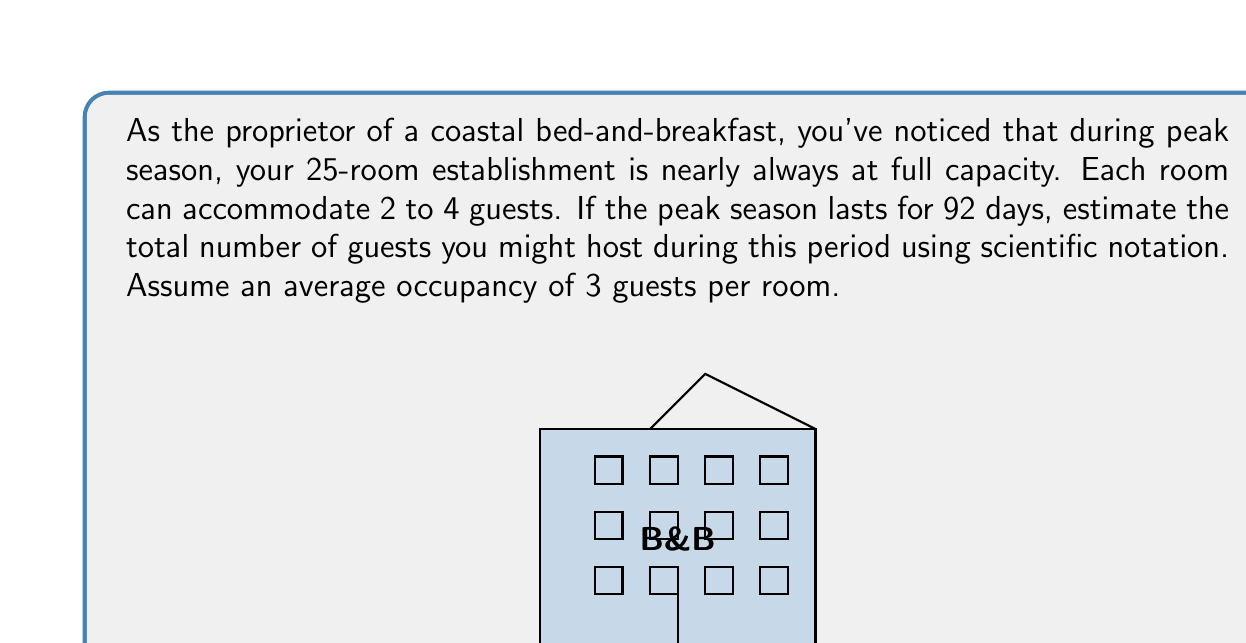Could you help me with this problem? Let's break this problem down step-by-step:

1) First, let's calculate the number of guests per day:
   $$ \text{Guests per day} = \text{Number of rooms} \times \text{Average guests per room} $$
   $$ \text{Guests per day} = 25 \times 3 = 75 $$

2) Now, let's calculate the total number of guests for the entire peak season:
   $$ \text{Total guests} = \text{Guests per day} \times \text{Number of days in peak season} $$
   $$ \text{Total guests} = 75 \times 92 = 6,900 $$

3) To express this in scientific notation, we need to write it in the form $a \times 10^n$, where $1 \leq a < 10$:
   $$ 6,900 = 6.9 \times 10^3 $$

Therefore, the estimated number of guests during peak season in scientific notation is $6.9 \times 10^3$.
Answer: $6.9 \times 10^3$ 